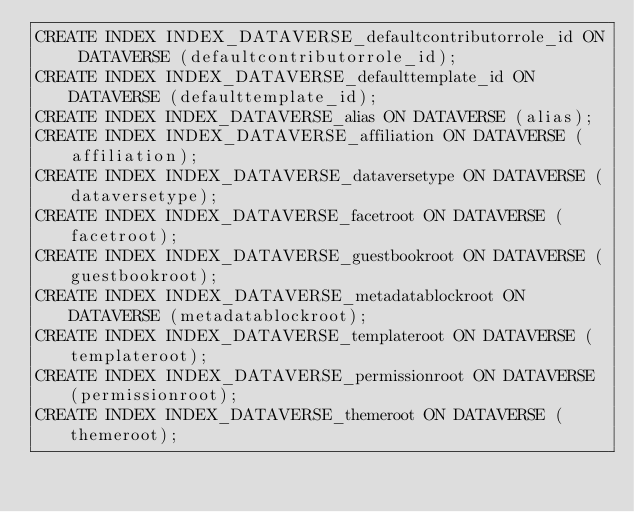Convert code to text. <code><loc_0><loc_0><loc_500><loc_500><_SQL_>CREATE INDEX INDEX_DATAVERSE_defaultcontributorrole_id ON DATAVERSE (defaultcontributorrole_id);
CREATE INDEX INDEX_DATAVERSE_defaulttemplate_id ON DATAVERSE (defaulttemplate_id);
CREATE INDEX INDEX_DATAVERSE_alias ON DATAVERSE (alias);
CREATE INDEX INDEX_DATAVERSE_affiliation ON DATAVERSE (affiliation);
CREATE INDEX INDEX_DATAVERSE_dataversetype ON DATAVERSE (dataversetype);
CREATE INDEX INDEX_DATAVERSE_facetroot ON DATAVERSE (facetroot);
CREATE INDEX INDEX_DATAVERSE_guestbookroot ON DATAVERSE (guestbookroot);
CREATE INDEX INDEX_DATAVERSE_metadatablockroot ON DATAVERSE (metadatablockroot);
CREATE INDEX INDEX_DATAVERSE_templateroot ON DATAVERSE (templateroot);
CREATE INDEX INDEX_DATAVERSE_permissionroot ON DATAVERSE (permissionroot);
CREATE INDEX INDEX_DATAVERSE_themeroot ON DATAVERSE (themeroot);</code> 